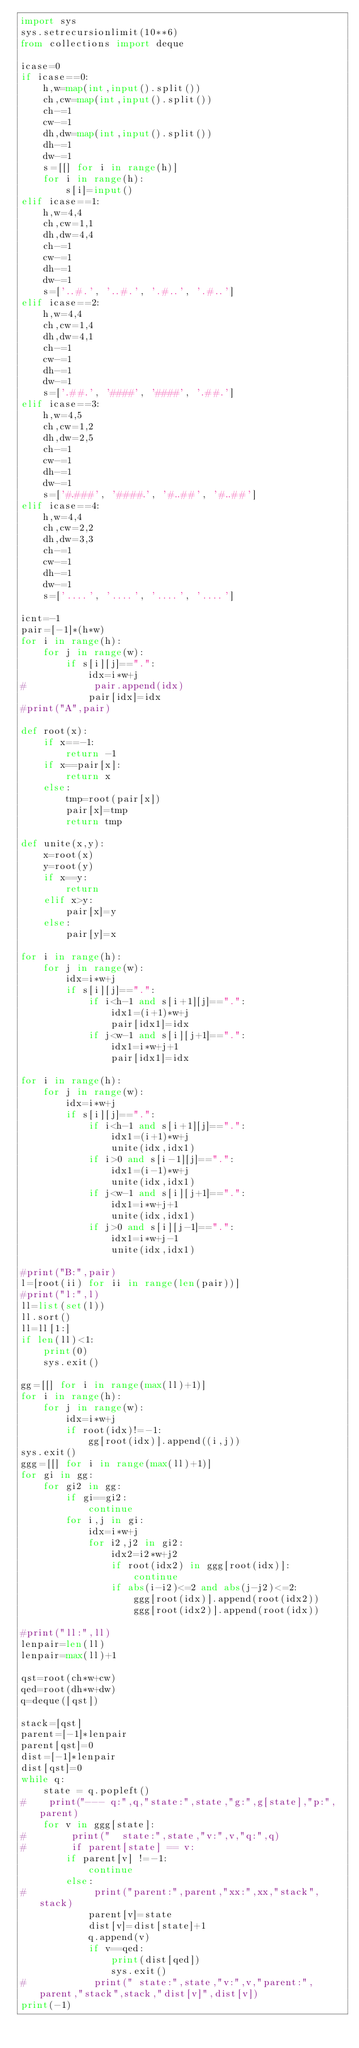Convert code to text. <code><loc_0><loc_0><loc_500><loc_500><_Python_>import sys
sys.setrecursionlimit(10**6)
from collections import deque

icase=0
if icase==0:
    h,w=map(int,input().split())
    ch,cw=map(int,input().split())
    ch-=1
    cw-=1
    dh,dw=map(int,input().split())
    dh-=1
    dw-=1
    s=[[] for i in range(h)]
    for i in range(h):
        s[i]=input()
elif icase==1:
    h,w=4,4
    ch,cw=1,1
    dh,dw=4,4
    ch-=1
    cw-=1
    dh-=1
    dw-=1
    s=['..#.', '..#.', '.#..', '.#..']   
elif icase==2:
    h,w=4,4
    ch,cw=1,4
    dh,dw=4,1
    ch-=1
    cw-=1
    dh-=1
    dw-=1
    s=['.##.', '####', '####', '.##.']  
elif icase==3:
    h,w=4,5
    ch,cw=1,2
    dh,dw=2,5
    ch-=1
    cw-=1
    dh-=1
    dw-=1
    s=['#.###', '####.', '#..##', '#..##'] 
elif icase==4:
    h,w=4,4
    ch,cw=2,2
    dh,dw=3,3
    ch-=1
    cw-=1
    dh-=1
    dw-=1
    s=['....', '....', '....', '....']
        
icnt=-1
pair=[-1]*(h*w)
for i in range(h):
    for j in range(w):
        if s[i][j]==".":
            idx=i*w+j
#            pair.append(idx)
            pair[idx]=idx
#print("A",pair)
               
def root(x):
    if x==-1:
        return -1
    if x==pair[x]:
        return x
    else:
        tmp=root(pair[x])
        pair[x]=tmp
        return tmp

def unite(x,y):
    x=root(x)
    y=root(y)
    if x==y:
        return
    elif x>y:
        pair[x]=y
    else:
        pair[y]=x
        
for i in range(h):
    for j in range(w):
        idx=i*w+j
        if s[i][j]==".":
            if i<h-1 and s[i+1][j]==".":
                idx1=(i+1)*w+j
                pair[idx1]=idx
            if j<w-1 and s[i][j+1]==".":
                idx1=i*w+j+1
                pair[idx1]=idx

for i in range(h):
    for j in range(w):
        idx=i*w+j
        if s[i][j]==".":
            if i<h-1 and s[i+1][j]==".":
                idx1=(i+1)*w+j
                unite(idx,idx1)
            if i>0 and s[i-1][j]==".":
                idx1=(i-1)*w+j
                unite(idx,idx1)
            if j<w-1 and s[i][j+1]==".":
                idx1=i*w+j+1
                unite(idx,idx1)
            if j>0 and s[i][j-1]==".":
                idx1=i*w+j-1
                unite(idx,idx1)

#print("B:",pair)
l=[root(ii) for ii in range(len(pair))]
#print("l:",l)
ll=list(set(l))    
ll.sort()
ll=ll[1:]
if len(ll)<1:
    print(0)
    sys.exit()

gg=[[] for i in range(max(ll)+1)]
for i in range(h):
    for j in range(w):
        idx=i*w+j
        if root(idx)!=-1:
            gg[root(idx)].append((i,j))        
sys.exit()
ggg=[[] for i in range(max(ll)+1)]
for gi in gg:
    for gi2 in gg:
        if gi==gi2:
            continue
        for i,j in gi:
            idx=i*w+j
            for i2,j2 in gi2:
                idx2=i2*w+j2
                if root(idx2) in ggg[root(idx)]:
                    continue
                if abs(i-i2)<=2 and abs(j-j2)<=2:
                    ggg[root(idx)].append(root(idx2))
                    ggg[root(idx2)].append(root(idx))

#print("ll:",ll)
lenpair=len(ll)    
lenpair=max(ll)+1

qst=root(ch*w+cw)
qed=root(dh*w+dw)
q=deque([qst])

stack=[qst]
parent=[-1]*lenpair
parent[qst]=0
dist=[-1]*lenpair
dist[qst]=0
while q:
    state = q.popleft()
#    print("--- q:",q,"state:",state,"g:",g[state],"p:",parent)
    for v in ggg[state]:
#        print("  state:",state,"v:",v,"q:",q)
#        if parent[state] == v:
        if parent[v] !=-1:
            continue
        else:
#            print("parent:",parent,"xx:",xx,"stack",stack)
            parent[v]=state
            dist[v]=dist[state]+1
            q.append(v)
            if v==qed:
                print(dist[qed])   
                sys.exit()
#            print(" state:",state,"v:",v,"parent:",parent,"stack",stack,"dist[v]",dist[v])
print(-1)   

</code> 